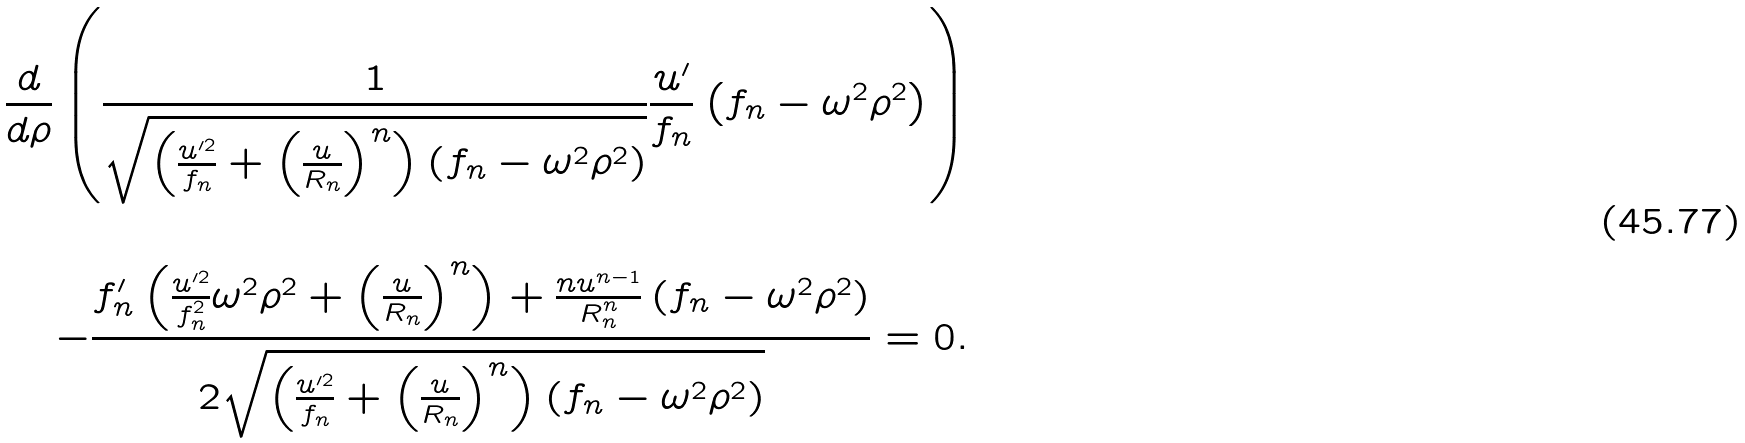Convert formula to latex. <formula><loc_0><loc_0><loc_500><loc_500>\frac { d } { d \rho } \left ( \frac { 1 } { \sqrt { \left ( \frac { u ^ { \prime 2 } } { f _ { n } } + \left ( \frac { u } { R _ { n } } \right ) ^ { n } \right ) \left ( f _ { n } - \omega ^ { 2 } \rho ^ { 2 } \right ) } } \frac { u ^ { \prime } } { f _ { n } } \left ( f _ { n } - \omega ^ { 2 } \rho ^ { 2 } \right ) \right ) \\ \\ \ - \frac { f _ { n } ^ { \prime } \left ( \frac { u ^ { \prime 2 } } { f _ { n } ^ { 2 } } \omega ^ { 2 } \rho ^ { 2 } + \left ( \frac { u } { R _ { n } } \right ) ^ { n } \right ) + \frac { n u ^ { n - 1 } } { R _ { n } ^ { n } } \left ( f _ { n } - \omega ^ { 2 } \rho ^ { 2 } \right ) } { 2 \sqrt { \left ( \frac { u ^ { \prime 2 } } { f _ { n } } + \left ( \frac { u } { R _ { n } } \right ) ^ { n } \right ) \left ( f _ { n } - \omega ^ { 2 } \rho ^ { 2 } \right ) } } = 0 .</formula> 